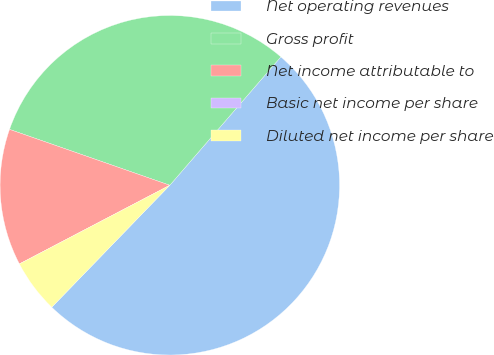<chart> <loc_0><loc_0><loc_500><loc_500><pie_chart><fcel>Net operating revenues<fcel>Gross profit<fcel>Net income attributable to<fcel>Basic net income per share<fcel>Diluted net income per share<nl><fcel>50.89%<fcel>31.01%<fcel>13.01%<fcel>0.0%<fcel>5.09%<nl></chart> 